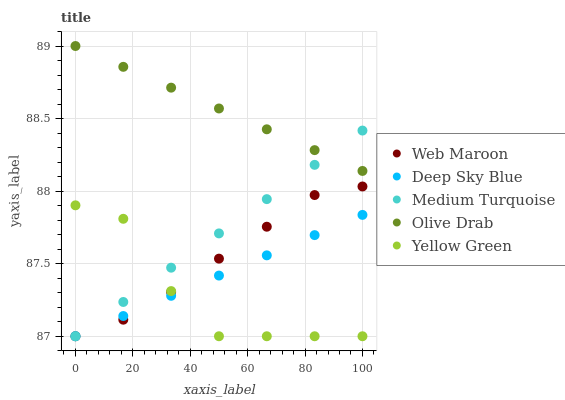Does Yellow Green have the minimum area under the curve?
Answer yes or no. Yes. Does Olive Drab have the maximum area under the curve?
Answer yes or no. Yes. Does Web Maroon have the minimum area under the curve?
Answer yes or no. No. Does Web Maroon have the maximum area under the curve?
Answer yes or no. No. Is Olive Drab the smoothest?
Answer yes or no. Yes. Is Yellow Green the roughest?
Answer yes or no. Yes. Is Web Maroon the smoothest?
Answer yes or no. No. Is Web Maroon the roughest?
Answer yes or no. No. Does Web Maroon have the lowest value?
Answer yes or no. Yes. Does Olive Drab have the highest value?
Answer yes or no. Yes. Does Web Maroon have the highest value?
Answer yes or no. No. Is Yellow Green less than Olive Drab?
Answer yes or no. Yes. Is Olive Drab greater than Deep Sky Blue?
Answer yes or no. Yes. Does Deep Sky Blue intersect Medium Turquoise?
Answer yes or no. Yes. Is Deep Sky Blue less than Medium Turquoise?
Answer yes or no. No. Is Deep Sky Blue greater than Medium Turquoise?
Answer yes or no. No. Does Yellow Green intersect Olive Drab?
Answer yes or no. No. 